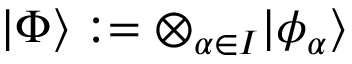<formula> <loc_0><loc_0><loc_500><loc_500>| \Phi \rangle \colon = \otimes _ { \alpha \in I } | \phi _ { \alpha } \rangle</formula> 